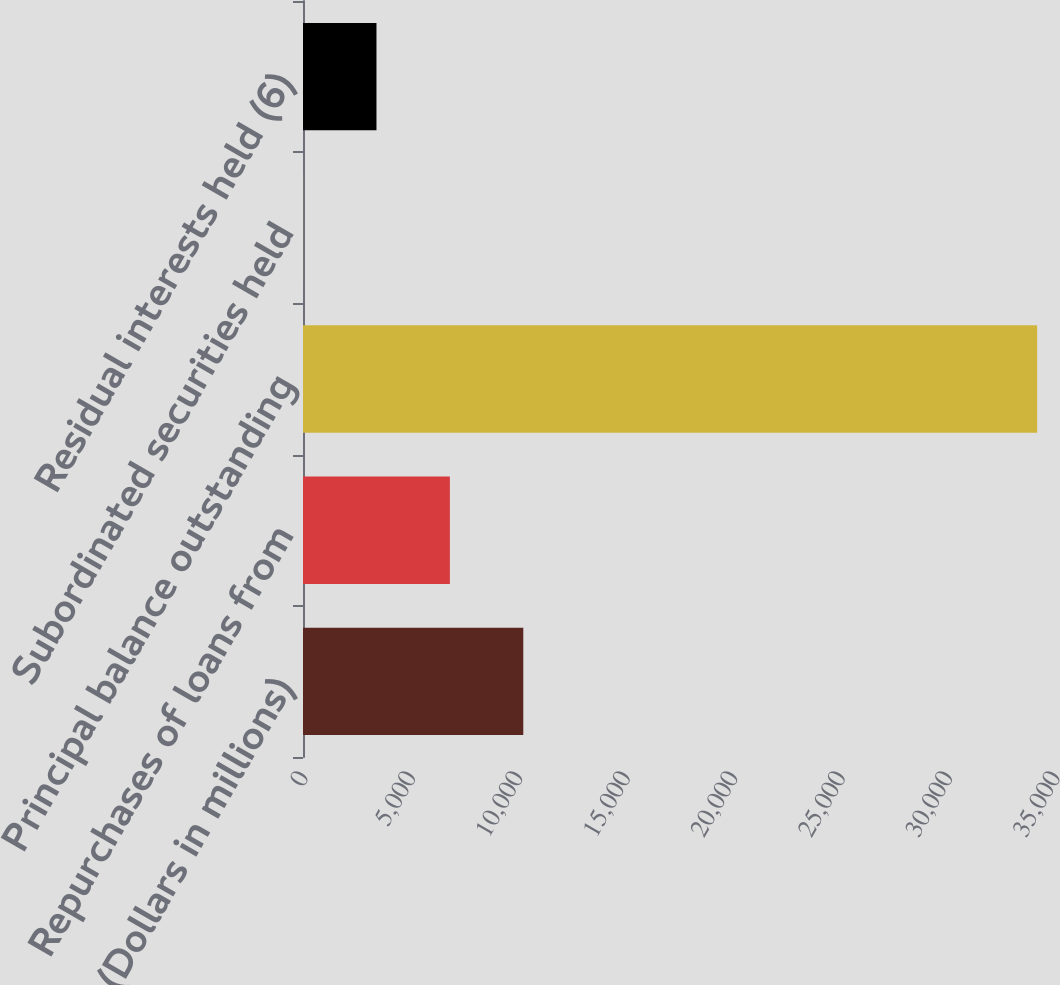<chart> <loc_0><loc_0><loc_500><loc_500><bar_chart><fcel>(Dollars in millions)<fcel>Repurchases of loans from<fcel>Principal balance outstanding<fcel>Subordinated securities held<fcel>Residual interests held (6)<nl><fcel>10252.8<fcel>6836.2<fcel>34169<fcel>3<fcel>3419.6<nl></chart> 